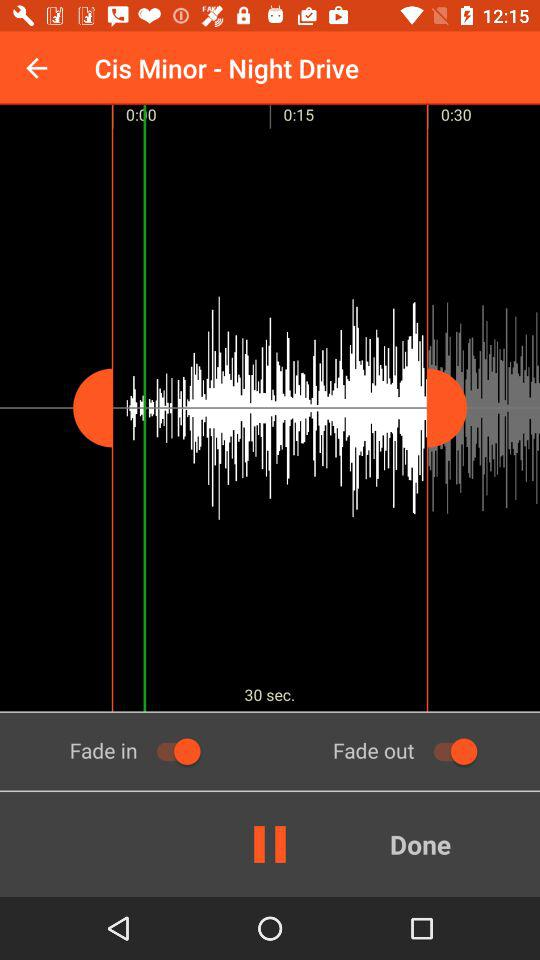What is the total duration? The total duration is 30 seconds. 